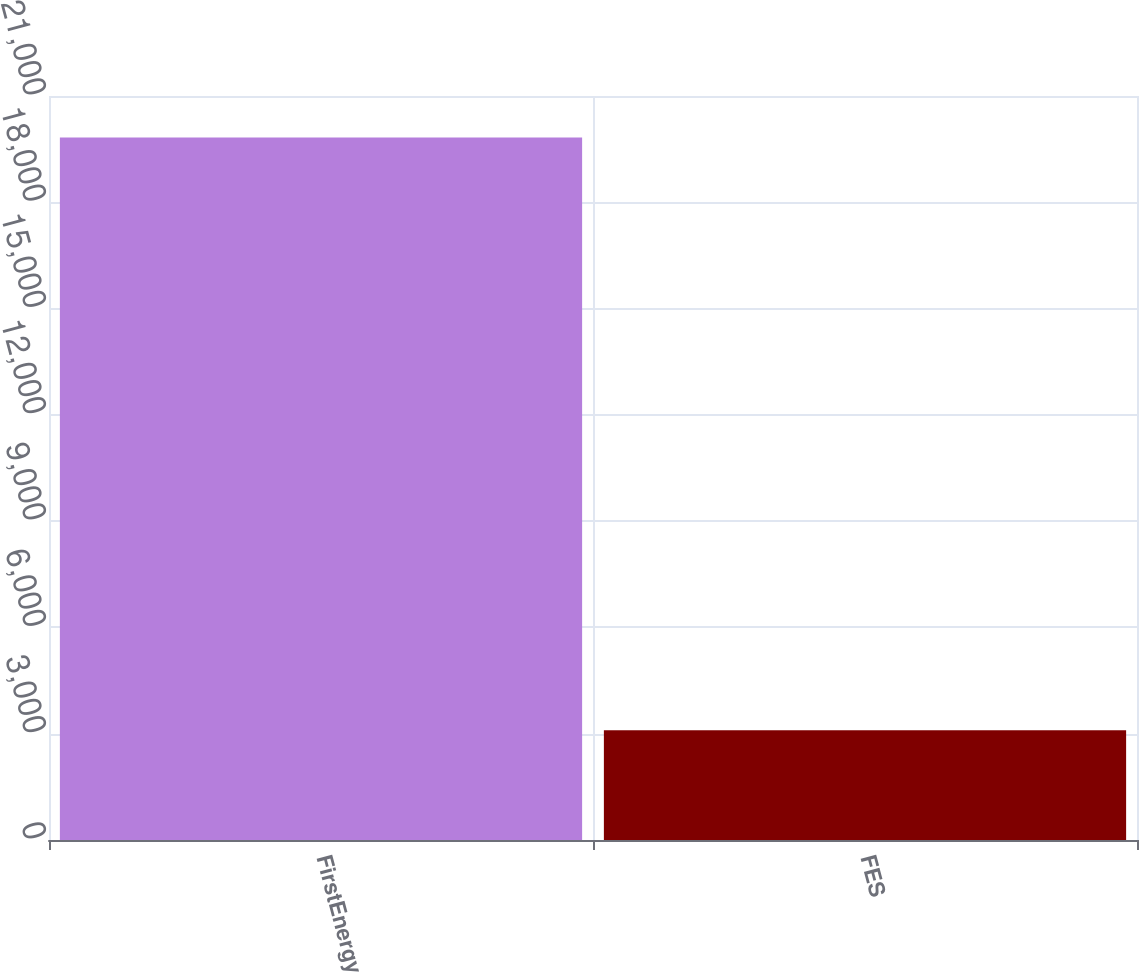<chart> <loc_0><loc_0><loc_500><loc_500><bar_chart><fcel>FirstEnergy<fcel>FES<nl><fcel>19828<fcel>3097<nl></chart> 